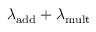Convert formula to latex. <formula><loc_0><loc_0><loc_500><loc_500>\lambda _ { a d d } + \lambda _ { m u l t }</formula> 